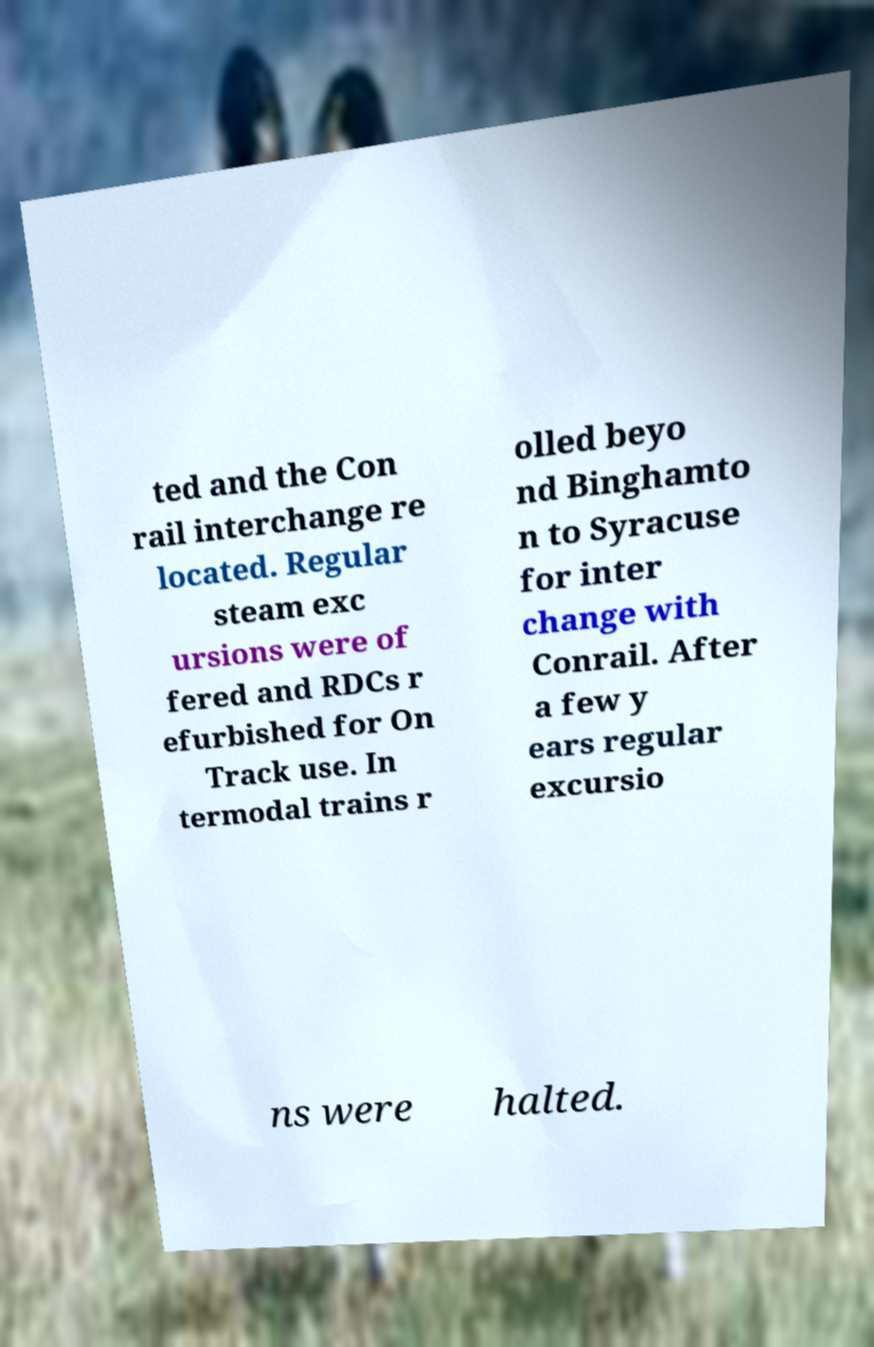I need the written content from this picture converted into text. Can you do that? ted and the Con rail interchange re located. Regular steam exc ursions were of fered and RDCs r efurbished for On Track use. In termodal trains r olled beyo nd Binghamto n to Syracuse for inter change with Conrail. After a few y ears regular excursio ns were halted. 